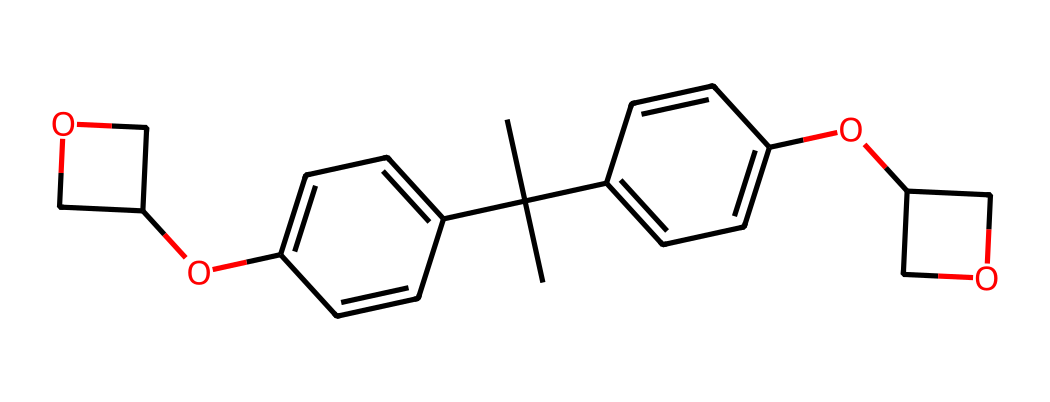How many carbon atoms are present in this compound? By identifying each "C" in the SMILES representation, I count a total of 22 carbon atoms throughout the entire molecule.
Answer: 22 What is the degree of unsaturation in this molecule? The degree of unsaturation can be calculated by evaluating the structure; each ring or double bond contributes to the count. In this case, there are five rings and various double bonds, leading to a degree of unsaturation of 11.
Answer: 11 Which functional group is represented by the "OC" in the structure? The "OC" part of the SMILES indicates the presence of an ether functional group characterized by an oxygen atom bonded between two carbon atoms.
Answer: ether Is this compound an aromatic compound? Checking for the presence of cyclic and conjugated structures, I find that there are indeed aromatic rings (specifically two phenyl groups), confirming that the compound is aromatic.
Answer: yes What type of reaction is this photoresist likely to undergo upon exposure to light? Negative photoresists are known to undergo cross-linking reactions when exposed to UV light which leads to increased molecular weight. This is typical behavior for a negative photoresist.
Answer: cross-linking Which part of the structure contributes to its solubility? The oxygen atoms in the ether groups and the structure overall provide polar characteristics that enhance the solubility of the compound in certain solvents.
Answer: ether groups 